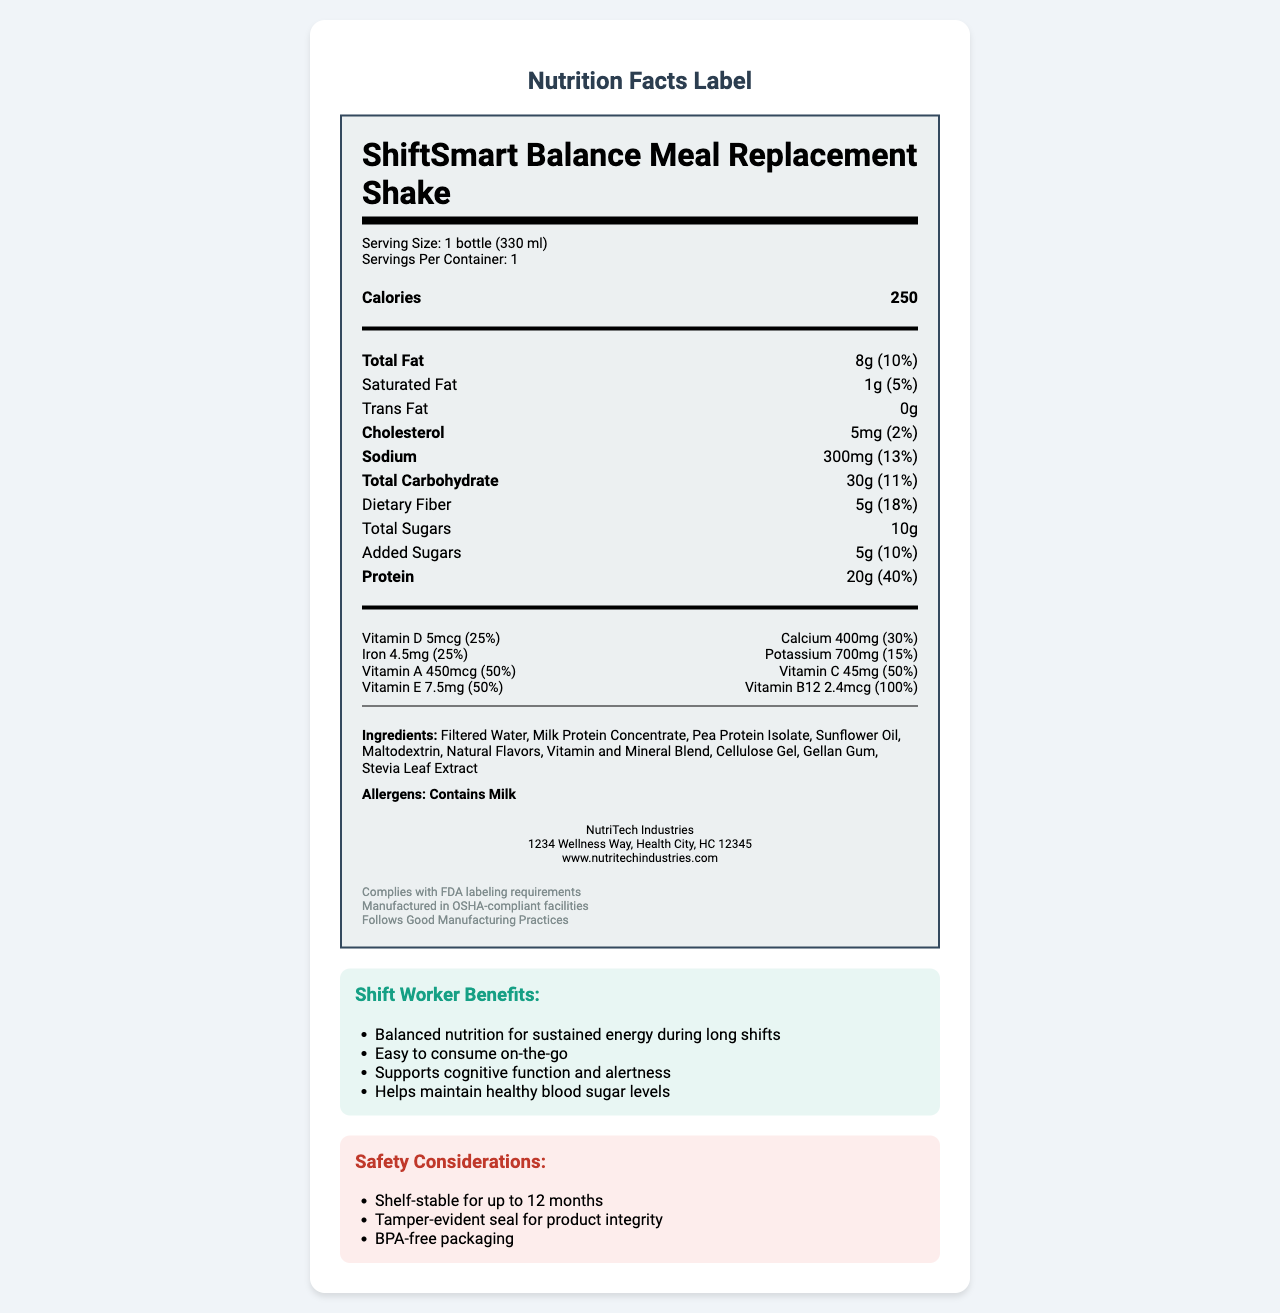what is the serving size of the ShiftSmart Balance Meal Replacement Shake? The serving size is stated in the "Serving Size" section of the nutrition facts label.
Answer: 1 bottle (330 ml) how many calories are there per serving? The number of calories per serving is indicated in the bold section labeled "Calories."
Answer: 250 what is the total fat content and its daily value percentage? The total fat content and its daily value percentage are listed in the "Total Fat" row.
Answer: 8g (10%) how much protein does the meal replacement shake contain, and what is its daily value percentage? The protein content and its daily value percentage are detailed in the "Protein" row.
Answer: 20g (40%) which allergens are present in this product? The allergens section identifies "Contains Milk" as an allergen present in the product.
Answer: Contains Milk what is the amount and daily value percentage of dietary fiber? The amount and daily value percentage of dietary fiber are listed in the "Dietary Fiber" row.
Answer: 5g (18%) what benefit does the meal replacement shake provide for shift workers? A. Supports muscle growth  B. Helps maintain healthy blood sugar levels  C. Promotes weight loss The benefits section for shift workers includes "Helps maintain healthy blood sugar levels."
Answer: B is this meal replacement shake suitable for individuals with a milk allergy? The allergens section states "Contains Milk," indicating it is not suitable for those with a milk allergy.
Answer: No what are the main features discussed in the document? The main features of the document include detailed nutritional information for the ShiftSmart Balance Meal Replacement Shake, shift worker benefits, safety considerations, ingredients, allergens, manufacturer information, and regulatory compliance.
Answer: Summary of Document what is the product's iron content and its daily value percentage? The iron content and daily value percentage are detailed in the "Iron" row.
Answer: 4.5mg (25%) which manufacturer produces the ShiftSmart Balance Meal Replacement Shake? A. Health Nutrients Inc.  B. NutriTech Industries  C. Vita Foods The manufacturer info section states "NutriTech Industries" as the producer of the shake.
Answer: B does the document include information on the price of the product? The document provides comprehensive details on nutritional content, safety, and benefits but does not include information about the product price.
Answer: Not enough information 